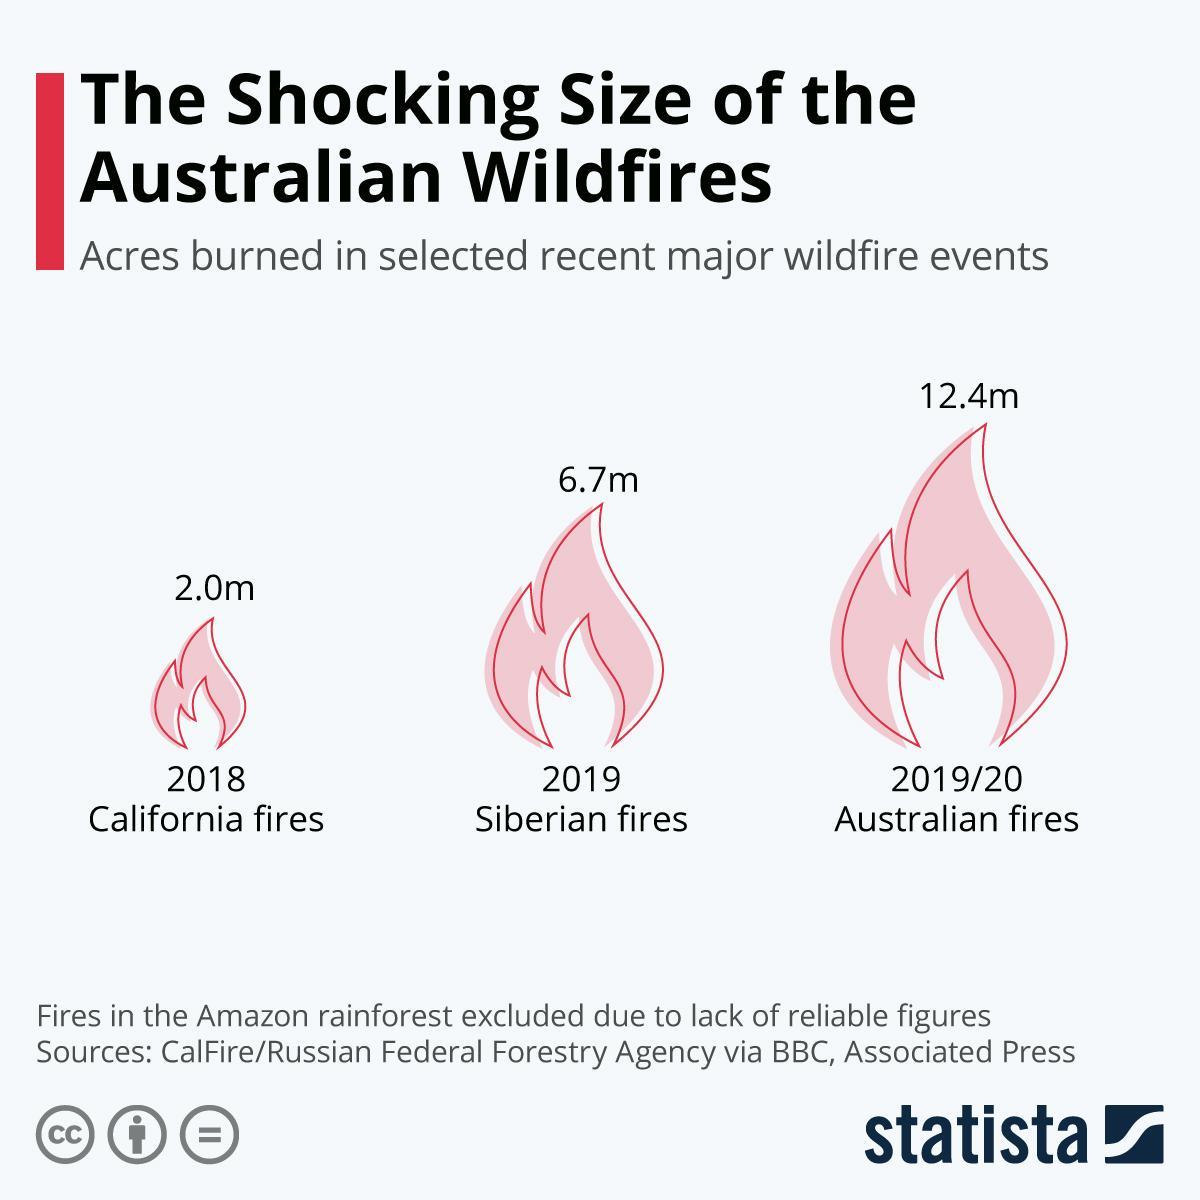How many acres were burned in Australian fires in 2019/20?
Answer the question with a short phrase. 12.4m What is the number of acres burned in Siberian fires in 2019? 6.7m What is the number of acres burned in California in 2018? 2.0m 